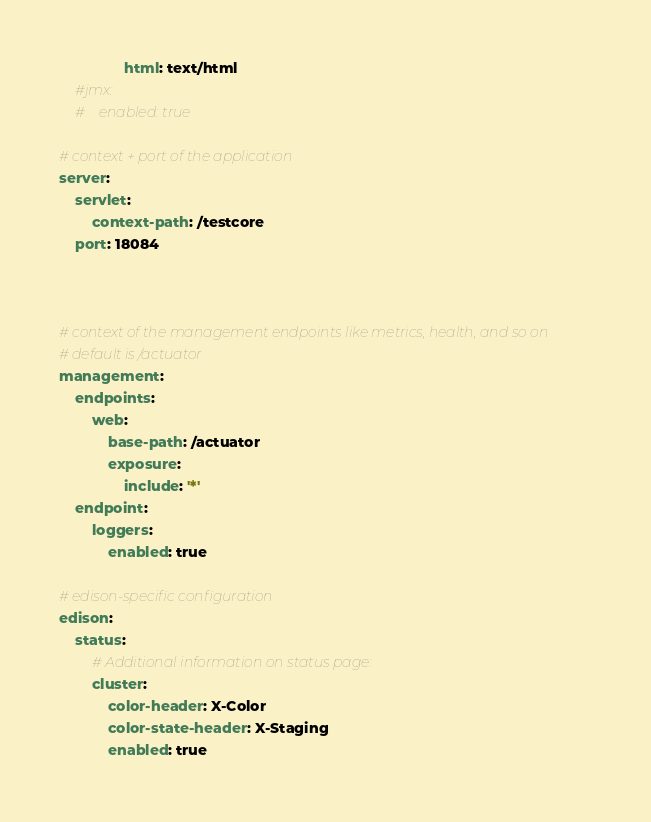<code> <loc_0><loc_0><loc_500><loc_500><_YAML_>                html: text/html
    #jmx:
    #    enabled: true

# context + port of the application
server:
    servlet:
        context-path: /testcore
    port: 18084



# context of the management endpoints like metrics, health, and so on
# default is /actuator
management:
    endpoints:
        web:
            base-path: /actuator
            exposure:
                include: '*'
    endpoint:
        loggers:
            enabled: true

# edison-specific configuration
edison:
    status:
        # Additional information on status page:
        cluster:
            color-header: X-Color
            color-state-header: X-Staging
            enabled: true
</code> 